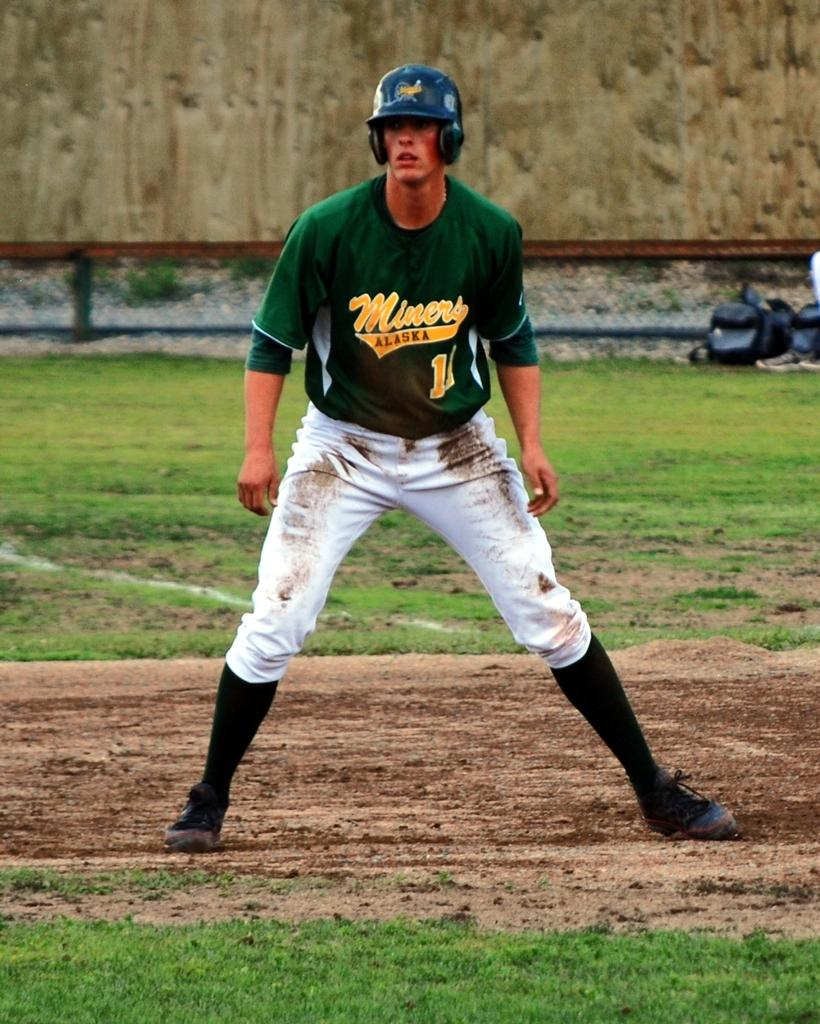<image>
Describe the image concisely. Man wearing a green jersey and says Miners on it. 